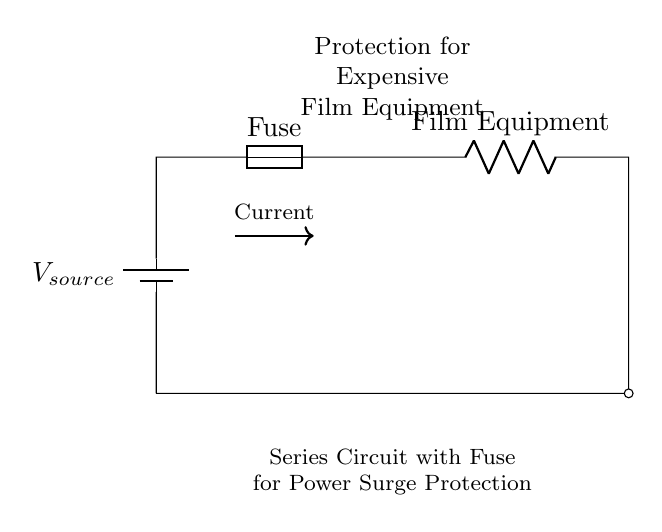What type of circuit is depicted in this diagram? The diagram illustrates a series circuit, where components are connected end-to-end, allowing current to flow through each component sequentially.
Answer: Series circuit What component is used to protect the film equipment? A fuse is included in the circuit to provide protection by breaking the circuit if too much current flows, thus preventing potential damage to the film equipment.
Answer: Fuse How many components are present in the circuit? The components in the circuit include a battery, a fuse, and the film equipment, making a total of three components in Series.
Answer: Three What is the purpose of the fuse in this circuit? The fuse serves to protect the circuit by blowing (or opening) when the current exceeds a certain threshold, thereby preventing damage to expensive equipment from power surges.
Answer: Protection Which way does the current flow in this circuit? The current flows from the positive terminal of the battery, through the fuse, into the film equipment, and back to the negative terminal of the battery in a continuous loop.
Answer: Clockwise What happens if the fuse blows? If the fuse blows, it creates an open circuit that stops the current from flowing, thus protecting the film equipment from being damaged due to excess current.
Answer: Stops current flow How does the arrangement of components affect current flow? In a series circuit, all components are connected in a single path, so the same current flows through each component. If one component fails, the entire circuit is interrupted.
Answer: Same current through each 